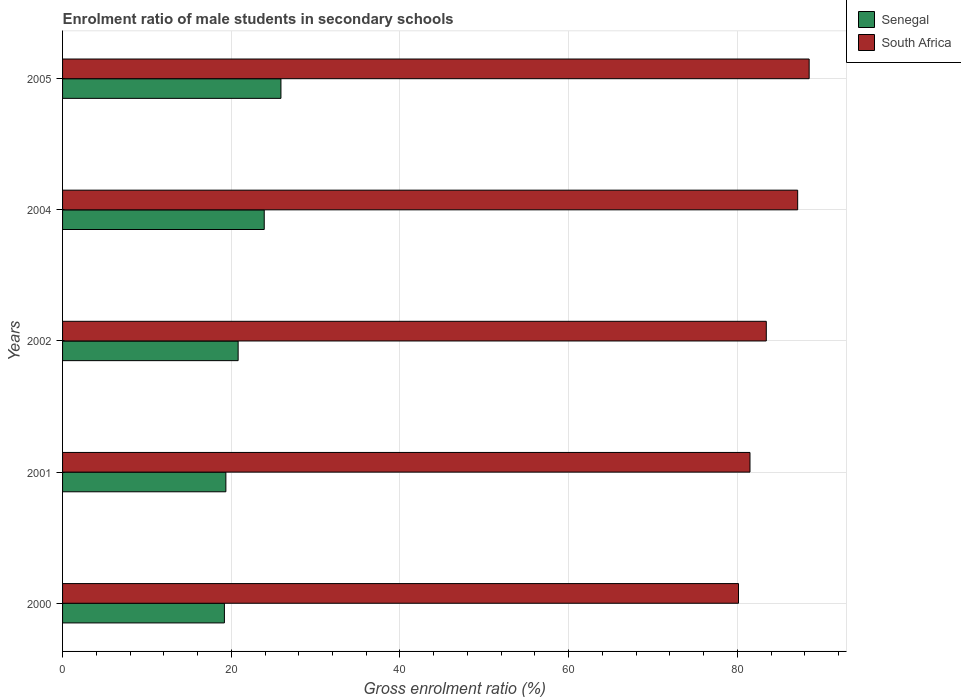How many different coloured bars are there?
Keep it short and to the point. 2. How many groups of bars are there?
Your answer should be compact. 5. Are the number of bars per tick equal to the number of legend labels?
Your answer should be compact. Yes. What is the label of the 1st group of bars from the top?
Your response must be concise. 2005. In how many cases, is the number of bars for a given year not equal to the number of legend labels?
Provide a short and direct response. 0. What is the enrolment ratio of male students in secondary schools in South Africa in 2000?
Ensure brevity in your answer.  80.14. Across all years, what is the maximum enrolment ratio of male students in secondary schools in Senegal?
Your response must be concise. 25.89. Across all years, what is the minimum enrolment ratio of male students in secondary schools in Senegal?
Your response must be concise. 19.19. In which year was the enrolment ratio of male students in secondary schools in Senegal maximum?
Make the answer very short. 2005. In which year was the enrolment ratio of male students in secondary schools in South Africa minimum?
Provide a short and direct response. 2000. What is the total enrolment ratio of male students in secondary schools in South Africa in the graph?
Offer a terse response. 420.73. What is the difference between the enrolment ratio of male students in secondary schools in South Africa in 2001 and that in 2002?
Provide a short and direct response. -1.93. What is the difference between the enrolment ratio of male students in secondary schools in South Africa in 2005 and the enrolment ratio of male students in secondary schools in Senegal in 2000?
Your answer should be compact. 69.33. What is the average enrolment ratio of male students in secondary schools in South Africa per year?
Provide a short and direct response. 84.15. In the year 2001, what is the difference between the enrolment ratio of male students in secondary schools in Senegal and enrolment ratio of male students in secondary schools in South Africa?
Your answer should be compact. -62.14. In how many years, is the enrolment ratio of male students in secondary schools in Senegal greater than 48 %?
Your response must be concise. 0. What is the ratio of the enrolment ratio of male students in secondary schools in Senegal in 2000 to that in 2004?
Your answer should be compact. 0.8. Is the enrolment ratio of male students in secondary schools in Senegal in 2004 less than that in 2005?
Your response must be concise. Yes. What is the difference between the highest and the second highest enrolment ratio of male students in secondary schools in South Africa?
Your response must be concise. 1.36. What is the difference between the highest and the lowest enrolment ratio of male students in secondary schools in South Africa?
Ensure brevity in your answer.  8.38. What does the 2nd bar from the top in 2004 represents?
Give a very brief answer. Senegal. What does the 2nd bar from the bottom in 2001 represents?
Make the answer very short. South Africa. How many bars are there?
Provide a short and direct response. 10. Are all the bars in the graph horizontal?
Provide a succinct answer. Yes. Are the values on the major ticks of X-axis written in scientific E-notation?
Your answer should be compact. No. Does the graph contain grids?
Ensure brevity in your answer.  Yes. Where does the legend appear in the graph?
Offer a very short reply. Top right. How are the legend labels stacked?
Provide a succinct answer. Vertical. What is the title of the graph?
Provide a short and direct response. Enrolment ratio of male students in secondary schools. What is the label or title of the X-axis?
Offer a terse response. Gross enrolment ratio (%). What is the label or title of the Y-axis?
Make the answer very short. Years. What is the Gross enrolment ratio (%) of Senegal in 2000?
Provide a short and direct response. 19.19. What is the Gross enrolment ratio (%) of South Africa in 2000?
Make the answer very short. 80.14. What is the Gross enrolment ratio (%) of Senegal in 2001?
Your answer should be compact. 19.36. What is the Gross enrolment ratio (%) in South Africa in 2001?
Offer a very short reply. 81.5. What is the Gross enrolment ratio (%) in Senegal in 2002?
Make the answer very short. 20.82. What is the Gross enrolment ratio (%) of South Africa in 2002?
Offer a terse response. 83.43. What is the Gross enrolment ratio (%) in Senegal in 2004?
Your answer should be compact. 23.91. What is the Gross enrolment ratio (%) in South Africa in 2004?
Keep it short and to the point. 87.15. What is the Gross enrolment ratio (%) in Senegal in 2005?
Provide a succinct answer. 25.89. What is the Gross enrolment ratio (%) in South Africa in 2005?
Ensure brevity in your answer.  88.51. Across all years, what is the maximum Gross enrolment ratio (%) in Senegal?
Make the answer very short. 25.89. Across all years, what is the maximum Gross enrolment ratio (%) of South Africa?
Offer a terse response. 88.51. Across all years, what is the minimum Gross enrolment ratio (%) in Senegal?
Keep it short and to the point. 19.19. Across all years, what is the minimum Gross enrolment ratio (%) in South Africa?
Offer a terse response. 80.14. What is the total Gross enrolment ratio (%) of Senegal in the graph?
Make the answer very short. 109.16. What is the total Gross enrolment ratio (%) of South Africa in the graph?
Offer a terse response. 420.73. What is the difference between the Gross enrolment ratio (%) in Senegal in 2000 and that in 2001?
Keep it short and to the point. -0.17. What is the difference between the Gross enrolment ratio (%) of South Africa in 2000 and that in 2001?
Give a very brief answer. -1.36. What is the difference between the Gross enrolment ratio (%) of Senegal in 2000 and that in 2002?
Provide a short and direct response. -1.63. What is the difference between the Gross enrolment ratio (%) of South Africa in 2000 and that in 2002?
Make the answer very short. -3.3. What is the difference between the Gross enrolment ratio (%) of Senegal in 2000 and that in 2004?
Your response must be concise. -4.72. What is the difference between the Gross enrolment ratio (%) of South Africa in 2000 and that in 2004?
Provide a short and direct response. -7.02. What is the difference between the Gross enrolment ratio (%) of Senegal in 2000 and that in 2005?
Your response must be concise. -6.7. What is the difference between the Gross enrolment ratio (%) of South Africa in 2000 and that in 2005?
Make the answer very short. -8.38. What is the difference between the Gross enrolment ratio (%) in Senegal in 2001 and that in 2002?
Your answer should be very brief. -1.45. What is the difference between the Gross enrolment ratio (%) in South Africa in 2001 and that in 2002?
Your answer should be very brief. -1.93. What is the difference between the Gross enrolment ratio (%) in Senegal in 2001 and that in 2004?
Ensure brevity in your answer.  -4.55. What is the difference between the Gross enrolment ratio (%) of South Africa in 2001 and that in 2004?
Your answer should be compact. -5.65. What is the difference between the Gross enrolment ratio (%) of Senegal in 2001 and that in 2005?
Provide a succinct answer. -6.53. What is the difference between the Gross enrolment ratio (%) of South Africa in 2001 and that in 2005?
Your answer should be compact. -7.02. What is the difference between the Gross enrolment ratio (%) of Senegal in 2002 and that in 2004?
Offer a terse response. -3.09. What is the difference between the Gross enrolment ratio (%) in South Africa in 2002 and that in 2004?
Keep it short and to the point. -3.72. What is the difference between the Gross enrolment ratio (%) in Senegal in 2002 and that in 2005?
Provide a short and direct response. -5.07. What is the difference between the Gross enrolment ratio (%) of South Africa in 2002 and that in 2005?
Your response must be concise. -5.08. What is the difference between the Gross enrolment ratio (%) in Senegal in 2004 and that in 2005?
Your answer should be very brief. -1.98. What is the difference between the Gross enrolment ratio (%) of South Africa in 2004 and that in 2005?
Your answer should be compact. -1.36. What is the difference between the Gross enrolment ratio (%) in Senegal in 2000 and the Gross enrolment ratio (%) in South Africa in 2001?
Give a very brief answer. -62.31. What is the difference between the Gross enrolment ratio (%) in Senegal in 2000 and the Gross enrolment ratio (%) in South Africa in 2002?
Offer a terse response. -64.24. What is the difference between the Gross enrolment ratio (%) in Senegal in 2000 and the Gross enrolment ratio (%) in South Africa in 2004?
Ensure brevity in your answer.  -67.97. What is the difference between the Gross enrolment ratio (%) of Senegal in 2000 and the Gross enrolment ratio (%) of South Africa in 2005?
Make the answer very short. -69.33. What is the difference between the Gross enrolment ratio (%) in Senegal in 2001 and the Gross enrolment ratio (%) in South Africa in 2002?
Offer a terse response. -64.07. What is the difference between the Gross enrolment ratio (%) of Senegal in 2001 and the Gross enrolment ratio (%) of South Africa in 2004?
Keep it short and to the point. -67.79. What is the difference between the Gross enrolment ratio (%) in Senegal in 2001 and the Gross enrolment ratio (%) in South Africa in 2005?
Make the answer very short. -69.15. What is the difference between the Gross enrolment ratio (%) of Senegal in 2002 and the Gross enrolment ratio (%) of South Africa in 2004?
Provide a short and direct response. -66.34. What is the difference between the Gross enrolment ratio (%) of Senegal in 2002 and the Gross enrolment ratio (%) of South Africa in 2005?
Offer a very short reply. -67.7. What is the difference between the Gross enrolment ratio (%) in Senegal in 2004 and the Gross enrolment ratio (%) in South Africa in 2005?
Your answer should be compact. -64.61. What is the average Gross enrolment ratio (%) in Senegal per year?
Keep it short and to the point. 21.83. What is the average Gross enrolment ratio (%) in South Africa per year?
Ensure brevity in your answer.  84.15. In the year 2000, what is the difference between the Gross enrolment ratio (%) of Senegal and Gross enrolment ratio (%) of South Africa?
Your answer should be compact. -60.95. In the year 2001, what is the difference between the Gross enrolment ratio (%) of Senegal and Gross enrolment ratio (%) of South Africa?
Provide a short and direct response. -62.14. In the year 2002, what is the difference between the Gross enrolment ratio (%) of Senegal and Gross enrolment ratio (%) of South Africa?
Offer a terse response. -62.62. In the year 2004, what is the difference between the Gross enrolment ratio (%) in Senegal and Gross enrolment ratio (%) in South Africa?
Provide a succinct answer. -63.24. In the year 2005, what is the difference between the Gross enrolment ratio (%) in Senegal and Gross enrolment ratio (%) in South Africa?
Provide a succinct answer. -62.62. What is the ratio of the Gross enrolment ratio (%) in South Africa in 2000 to that in 2001?
Give a very brief answer. 0.98. What is the ratio of the Gross enrolment ratio (%) of Senegal in 2000 to that in 2002?
Your answer should be compact. 0.92. What is the ratio of the Gross enrolment ratio (%) of South Africa in 2000 to that in 2002?
Give a very brief answer. 0.96. What is the ratio of the Gross enrolment ratio (%) of Senegal in 2000 to that in 2004?
Provide a short and direct response. 0.8. What is the ratio of the Gross enrolment ratio (%) in South Africa in 2000 to that in 2004?
Offer a terse response. 0.92. What is the ratio of the Gross enrolment ratio (%) of Senegal in 2000 to that in 2005?
Make the answer very short. 0.74. What is the ratio of the Gross enrolment ratio (%) in South Africa in 2000 to that in 2005?
Offer a terse response. 0.91. What is the ratio of the Gross enrolment ratio (%) of Senegal in 2001 to that in 2002?
Give a very brief answer. 0.93. What is the ratio of the Gross enrolment ratio (%) of South Africa in 2001 to that in 2002?
Keep it short and to the point. 0.98. What is the ratio of the Gross enrolment ratio (%) of Senegal in 2001 to that in 2004?
Offer a terse response. 0.81. What is the ratio of the Gross enrolment ratio (%) of South Africa in 2001 to that in 2004?
Ensure brevity in your answer.  0.94. What is the ratio of the Gross enrolment ratio (%) in Senegal in 2001 to that in 2005?
Your response must be concise. 0.75. What is the ratio of the Gross enrolment ratio (%) in South Africa in 2001 to that in 2005?
Give a very brief answer. 0.92. What is the ratio of the Gross enrolment ratio (%) of Senegal in 2002 to that in 2004?
Keep it short and to the point. 0.87. What is the ratio of the Gross enrolment ratio (%) in South Africa in 2002 to that in 2004?
Your response must be concise. 0.96. What is the ratio of the Gross enrolment ratio (%) of Senegal in 2002 to that in 2005?
Ensure brevity in your answer.  0.8. What is the ratio of the Gross enrolment ratio (%) in South Africa in 2002 to that in 2005?
Your answer should be very brief. 0.94. What is the ratio of the Gross enrolment ratio (%) of Senegal in 2004 to that in 2005?
Provide a short and direct response. 0.92. What is the ratio of the Gross enrolment ratio (%) in South Africa in 2004 to that in 2005?
Offer a terse response. 0.98. What is the difference between the highest and the second highest Gross enrolment ratio (%) of Senegal?
Offer a very short reply. 1.98. What is the difference between the highest and the second highest Gross enrolment ratio (%) of South Africa?
Your answer should be compact. 1.36. What is the difference between the highest and the lowest Gross enrolment ratio (%) of Senegal?
Provide a succinct answer. 6.7. What is the difference between the highest and the lowest Gross enrolment ratio (%) in South Africa?
Your answer should be compact. 8.38. 